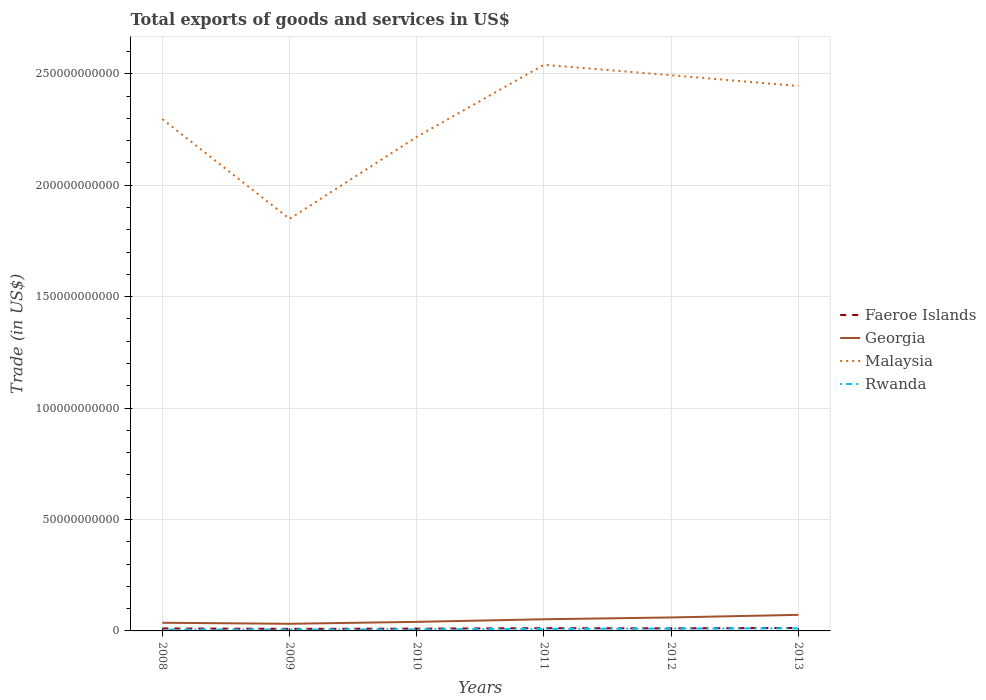How many different coloured lines are there?
Your answer should be compact. 4. Is the number of lines equal to the number of legend labels?
Your answer should be very brief. Yes. Across all years, what is the maximum total exports of goods and services in Faeroe Islands?
Keep it short and to the point. 9.34e+08. In which year was the total exports of goods and services in Georgia maximum?
Give a very brief answer. 2009. What is the total total exports of goods and services in Faeroe Islands in the graph?
Make the answer very short. -1.75e+08. What is the difference between the highest and the second highest total exports of goods and services in Georgia?
Offer a terse response. 4.01e+09. Is the total exports of goods and services in Faeroe Islands strictly greater than the total exports of goods and services in Georgia over the years?
Make the answer very short. Yes. How many lines are there?
Keep it short and to the point. 4. How many years are there in the graph?
Offer a terse response. 6. Are the values on the major ticks of Y-axis written in scientific E-notation?
Offer a very short reply. No. How are the legend labels stacked?
Provide a succinct answer. Vertical. What is the title of the graph?
Offer a very short reply. Total exports of goods and services in US$. Does "Grenada" appear as one of the legend labels in the graph?
Make the answer very short. No. What is the label or title of the X-axis?
Your answer should be very brief. Years. What is the label or title of the Y-axis?
Provide a succinct answer. Trade (in US$). What is the Trade (in US$) of Faeroe Islands in 2008?
Your answer should be compact. 1.10e+09. What is the Trade (in US$) of Georgia in 2008?
Give a very brief answer. 3.66e+09. What is the Trade (in US$) in Malaysia in 2008?
Give a very brief answer. 2.30e+11. What is the Trade (in US$) in Rwanda in 2008?
Your answer should be very brief. 6.11e+08. What is the Trade (in US$) of Faeroe Islands in 2009?
Your answer should be very brief. 9.34e+08. What is the Trade (in US$) in Georgia in 2009?
Give a very brief answer. 3.20e+09. What is the Trade (in US$) of Malaysia in 2009?
Offer a terse response. 1.85e+11. What is the Trade (in US$) of Rwanda in 2009?
Provide a succinct answer. 6.32e+08. What is the Trade (in US$) of Faeroe Islands in 2010?
Keep it short and to the point. 1.03e+09. What is the Trade (in US$) of Georgia in 2010?
Make the answer very short. 4.07e+09. What is the Trade (in US$) of Malaysia in 2010?
Your answer should be compact. 2.22e+11. What is the Trade (in US$) of Rwanda in 2010?
Your answer should be compact. 6.89e+08. What is the Trade (in US$) of Faeroe Islands in 2011?
Ensure brevity in your answer.  1.21e+09. What is the Trade (in US$) of Georgia in 2011?
Provide a succinct answer. 5.23e+09. What is the Trade (in US$) in Malaysia in 2011?
Your response must be concise. 2.54e+11. What is the Trade (in US$) in Rwanda in 2011?
Ensure brevity in your answer.  9.25e+08. What is the Trade (in US$) of Faeroe Islands in 2012?
Provide a succinct answer. 1.15e+09. What is the Trade (in US$) of Georgia in 2012?
Your response must be concise. 6.05e+09. What is the Trade (in US$) in Malaysia in 2012?
Offer a very short reply. 2.49e+11. What is the Trade (in US$) in Rwanda in 2012?
Provide a short and direct response. 1.02e+09. What is the Trade (in US$) in Faeroe Islands in 2013?
Offer a terse response. 1.32e+09. What is the Trade (in US$) in Georgia in 2013?
Provide a short and direct response. 7.21e+09. What is the Trade (in US$) of Malaysia in 2013?
Provide a succinct answer. 2.44e+11. What is the Trade (in US$) in Rwanda in 2013?
Your answer should be very brief. 1.18e+09. Across all years, what is the maximum Trade (in US$) of Faeroe Islands?
Your answer should be compact. 1.32e+09. Across all years, what is the maximum Trade (in US$) in Georgia?
Keep it short and to the point. 7.21e+09. Across all years, what is the maximum Trade (in US$) in Malaysia?
Your answer should be very brief. 2.54e+11. Across all years, what is the maximum Trade (in US$) of Rwanda?
Make the answer very short. 1.18e+09. Across all years, what is the minimum Trade (in US$) of Faeroe Islands?
Your answer should be very brief. 9.34e+08. Across all years, what is the minimum Trade (in US$) in Georgia?
Offer a very short reply. 3.20e+09. Across all years, what is the minimum Trade (in US$) in Malaysia?
Provide a succinct answer. 1.85e+11. Across all years, what is the minimum Trade (in US$) of Rwanda?
Your answer should be very brief. 6.11e+08. What is the total Trade (in US$) in Faeroe Islands in the graph?
Provide a succinct answer. 6.75e+09. What is the total Trade (in US$) of Georgia in the graph?
Provide a succinct answer. 2.94e+1. What is the total Trade (in US$) in Malaysia in the graph?
Offer a terse response. 1.38e+12. What is the total Trade (in US$) in Rwanda in the graph?
Your response must be concise. 5.05e+09. What is the difference between the Trade (in US$) of Faeroe Islands in 2008 and that in 2009?
Your answer should be compact. 1.70e+08. What is the difference between the Trade (in US$) in Georgia in 2008 and that in 2009?
Make the answer very short. 4.60e+08. What is the difference between the Trade (in US$) in Malaysia in 2008 and that in 2009?
Offer a very short reply. 4.48e+1. What is the difference between the Trade (in US$) of Rwanda in 2008 and that in 2009?
Provide a succinct answer. -2.10e+07. What is the difference between the Trade (in US$) of Faeroe Islands in 2008 and that in 2010?
Ensure brevity in your answer.  7.86e+07. What is the difference between the Trade (in US$) of Georgia in 2008 and that in 2010?
Give a very brief answer. -4.06e+08. What is the difference between the Trade (in US$) in Malaysia in 2008 and that in 2010?
Give a very brief answer. 7.97e+09. What is the difference between the Trade (in US$) of Rwanda in 2008 and that in 2010?
Keep it short and to the point. -7.86e+07. What is the difference between the Trade (in US$) in Faeroe Islands in 2008 and that in 2011?
Offer a very short reply. -1.08e+08. What is the difference between the Trade (in US$) of Georgia in 2008 and that in 2011?
Your answer should be compact. -1.57e+09. What is the difference between the Trade (in US$) in Malaysia in 2008 and that in 2011?
Your response must be concise. -2.44e+1. What is the difference between the Trade (in US$) in Rwanda in 2008 and that in 2011?
Make the answer very short. -3.14e+08. What is the difference between the Trade (in US$) of Faeroe Islands in 2008 and that in 2012?
Your answer should be very brief. -4.44e+07. What is the difference between the Trade (in US$) in Georgia in 2008 and that in 2012?
Offer a very short reply. -2.38e+09. What is the difference between the Trade (in US$) in Malaysia in 2008 and that in 2012?
Offer a terse response. -1.97e+1. What is the difference between the Trade (in US$) in Rwanda in 2008 and that in 2012?
Your answer should be very brief. -4.10e+08. What is the difference between the Trade (in US$) of Faeroe Islands in 2008 and that in 2013?
Offer a very short reply. -2.19e+08. What is the difference between the Trade (in US$) in Georgia in 2008 and that in 2013?
Provide a short and direct response. -3.55e+09. What is the difference between the Trade (in US$) in Malaysia in 2008 and that in 2013?
Make the answer very short. -1.48e+1. What is the difference between the Trade (in US$) of Rwanda in 2008 and that in 2013?
Ensure brevity in your answer.  -5.65e+08. What is the difference between the Trade (in US$) of Faeroe Islands in 2009 and that in 2010?
Offer a terse response. -9.14e+07. What is the difference between the Trade (in US$) in Georgia in 2009 and that in 2010?
Make the answer very short. -8.66e+08. What is the difference between the Trade (in US$) in Malaysia in 2009 and that in 2010?
Offer a very short reply. -3.68e+1. What is the difference between the Trade (in US$) of Rwanda in 2009 and that in 2010?
Offer a terse response. -5.77e+07. What is the difference between the Trade (in US$) of Faeroe Islands in 2009 and that in 2011?
Offer a very short reply. -2.78e+08. What is the difference between the Trade (in US$) in Georgia in 2009 and that in 2011?
Your answer should be compact. -2.03e+09. What is the difference between the Trade (in US$) of Malaysia in 2009 and that in 2011?
Provide a short and direct response. -6.91e+1. What is the difference between the Trade (in US$) of Rwanda in 2009 and that in 2011?
Your answer should be very brief. -2.93e+08. What is the difference between the Trade (in US$) of Faeroe Islands in 2009 and that in 2012?
Your answer should be compact. -2.14e+08. What is the difference between the Trade (in US$) in Georgia in 2009 and that in 2012?
Offer a very short reply. -2.84e+09. What is the difference between the Trade (in US$) in Malaysia in 2009 and that in 2012?
Make the answer very short. -6.45e+1. What is the difference between the Trade (in US$) of Rwanda in 2009 and that in 2012?
Your answer should be very brief. -3.89e+08. What is the difference between the Trade (in US$) of Faeroe Islands in 2009 and that in 2013?
Ensure brevity in your answer.  -3.89e+08. What is the difference between the Trade (in US$) in Georgia in 2009 and that in 2013?
Provide a short and direct response. -4.01e+09. What is the difference between the Trade (in US$) of Malaysia in 2009 and that in 2013?
Ensure brevity in your answer.  -5.96e+1. What is the difference between the Trade (in US$) in Rwanda in 2009 and that in 2013?
Ensure brevity in your answer.  -5.44e+08. What is the difference between the Trade (in US$) in Faeroe Islands in 2010 and that in 2011?
Your answer should be very brief. -1.87e+08. What is the difference between the Trade (in US$) in Georgia in 2010 and that in 2011?
Your answer should be compact. -1.16e+09. What is the difference between the Trade (in US$) of Malaysia in 2010 and that in 2011?
Keep it short and to the point. -3.23e+1. What is the difference between the Trade (in US$) in Rwanda in 2010 and that in 2011?
Your answer should be very brief. -2.35e+08. What is the difference between the Trade (in US$) of Faeroe Islands in 2010 and that in 2012?
Give a very brief answer. -1.23e+08. What is the difference between the Trade (in US$) in Georgia in 2010 and that in 2012?
Provide a succinct answer. -1.98e+09. What is the difference between the Trade (in US$) in Malaysia in 2010 and that in 2012?
Ensure brevity in your answer.  -2.77e+1. What is the difference between the Trade (in US$) of Rwanda in 2010 and that in 2012?
Offer a very short reply. -3.31e+08. What is the difference between the Trade (in US$) of Faeroe Islands in 2010 and that in 2013?
Make the answer very short. -2.98e+08. What is the difference between the Trade (in US$) of Georgia in 2010 and that in 2013?
Give a very brief answer. -3.15e+09. What is the difference between the Trade (in US$) in Malaysia in 2010 and that in 2013?
Provide a succinct answer. -2.28e+1. What is the difference between the Trade (in US$) in Rwanda in 2010 and that in 2013?
Your response must be concise. -4.86e+08. What is the difference between the Trade (in US$) in Faeroe Islands in 2011 and that in 2012?
Offer a very short reply. 6.40e+07. What is the difference between the Trade (in US$) in Georgia in 2011 and that in 2012?
Your response must be concise. -8.14e+08. What is the difference between the Trade (in US$) of Malaysia in 2011 and that in 2012?
Provide a short and direct response. 4.67e+09. What is the difference between the Trade (in US$) in Rwanda in 2011 and that in 2012?
Provide a short and direct response. -9.62e+07. What is the difference between the Trade (in US$) in Faeroe Islands in 2011 and that in 2013?
Provide a short and direct response. -1.11e+08. What is the difference between the Trade (in US$) in Georgia in 2011 and that in 2013?
Offer a terse response. -1.98e+09. What is the difference between the Trade (in US$) of Malaysia in 2011 and that in 2013?
Give a very brief answer. 9.53e+09. What is the difference between the Trade (in US$) of Rwanda in 2011 and that in 2013?
Give a very brief answer. -2.51e+08. What is the difference between the Trade (in US$) of Faeroe Islands in 2012 and that in 2013?
Your answer should be compact. -1.75e+08. What is the difference between the Trade (in US$) of Georgia in 2012 and that in 2013?
Your answer should be compact. -1.17e+09. What is the difference between the Trade (in US$) of Malaysia in 2012 and that in 2013?
Keep it short and to the point. 4.86e+09. What is the difference between the Trade (in US$) in Rwanda in 2012 and that in 2013?
Give a very brief answer. -1.55e+08. What is the difference between the Trade (in US$) of Faeroe Islands in 2008 and the Trade (in US$) of Georgia in 2009?
Provide a succinct answer. -2.10e+09. What is the difference between the Trade (in US$) in Faeroe Islands in 2008 and the Trade (in US$) in Malaysia in 2009?
Your response must be concise. -1.84e+11. What is the difference between the Trade (in US$) of Faeroe Islands in 2008 and the Trade (in US$) of Rwanda in 2009?
Ensure brevity in your answer.  4.73e+08. What is the difference between the Trade (in US$) in Georgia in 2008 and the Trade (in US$) in Malaysia in 2009?
Your answer should be very brief. -1.81e+11. What is the difference between the Trade (in US$) in Georgia in 2008 and the Trade (in US$) in Rwanda in 2009?
Make the answer very short. 3.03e+09. What is the difference between the Trade (in US$) of Malaysia in 2008 and the Trade (in US$) of Rwanda in 2009?
Give a very brief answer. 2.29e+11. What is the difference between the Trade (in US$) in Faeroe Islands in 2008 and the Trade (in US$) in Georgia in 2010?
Provide a succinct answer. -2.96e+09. What is the difference between the Trade (in US$) of Faeroe Islands in 2008 and the Trade (in US$) of Malaysia in 2010?
Give a very brief answer. -2.21e+11. What is the difference between the Trade (in US$) in Faeroe Islands in 2008 and the Trade (in US$) in Rwanda in 2010?
Ensure brevity in your answer.  4.15e+08. What is the difference between the Trade (in US$) in Georgia in 2008 and the Trade (in US$) in Malaysia in 2010?
Keep it short and to the point. -2.18e+11. What is the difference between the Trade (in US$) of Georgia in 2008 and the Trade (in US$) of Rwanda in 2010?
Offer a very short reply. 2.97e+09. What is the difference between the Trade (in US$) in Malaysia in 2008 and the Trade (in US$) in Rwanda in 2010?
Your answer should be compact. 2.29e+11. What is the difference between the Trade (in US$) of Faeroe Islands in 2008 and the Trade (in US$) of Georgia in 2011?
Offer a very short reply. -4.13e+09. What is the difference between the Trade (in US$) in Faeroe Islands in 2008 and the Trade (in US$) in Malaysia in 2011?
Keep it short and to the point. -2.53e+11. What is the difference between the Trade (in US$) of Faeroe Islands in 2008 and the Trade (in US$) of Rwanda in 2011?
Provide a short and direct response. 1.80e+08. What is the difference between the Trade (in US$) in Georgia in 2008 and the Trade (in US$) in Malaysia in 2011?
Provide a succinct answer. -2.50e+11. What is the difference between the Trade (in US$) in Georgia in 2008 and the Trade (in US$) in Rwanda in 2011?
Ensure brevity in your answer.  2.74e+09. What is the difference between the Trade (in US$) of Malaysia in 2008 and the Trade (in US$) of Rwanda in 2011?
Provide a succinct answer. 2.29e+11. What is the difference between the Trade (in US$) of Faeroe Islands in 2008 and the Trade (in US$) of Georgia in 2012?
Keep it short and to the point. -4.94e+09. What is the difference between the Trade (in US$) of Faeroe Islands in 2008 and the Trade (in US$) of Malaysia in 2012?
Provide a succinct answer. -2.48e+11. What is the difference between the Trade (in US$) in Faeroe Islands in 2008 and the Trade (in US$) in Rwanda in 2012?
Make the answer very short. 8.36e+07. What is the difference between the Trade (in US$) in Georgia in 2008 and the Trade (in US$) in Malaysia in 2012?
Keep it short and to the point. -2.46e+11. What is the difference between the Trade (in US$) of Georgia in 2008 and the Trade (in US$) of Rwanda in 2012?
Your response must be concise. 2.64e+09. What is the difference between the Trade (in US$) of Malaysia in 2008 and the Trade (in US$) of Rwanda in 2012?
Provide a succinct answer. 2.29e+11. What is the difference between the Trade (in US$) of Faeroe Islands in 2008 and the Trade (in US$) of Georgia in 2013?
Your response must be concise. -6.11e+09. What is the difference between the Trade (in US$) of Faeroe Islands in 2008 and the Trade (in US$) of Malaysia in 2013?
Ensure brevity in your answer.  -2.43e+11. What is the difference between the Trade (in US$) of Faeroe Islands in 2008 and the Trade (in US$) of Rwanda in 2013?
Offer a very short reply. -7.10e+07. What is the difference between the Trade (in US$) of Georgia in 2008 and the Trade (in US$) of Malaysia in 2013?
Give a very brief answer. -2.41e+11. What is the difference between the Trade (in US$) of Georgia in 2008 and the Trade (in US$) of Rwanda in 2013?
Your response must be concise. 2.49e+09. What is the difference between the Trade (in US$) in Malaysia in 2008 and the Trade (in US$) in Rwanda in 2013?
Provide a succinct answer. 2.28e+11. What is the difference between the Trade (in US$) in Faeroe Islands in 2009 and the Trade (in US$) in Georgia in 2010?
Keep it short and to the point. -3.13e+09. What is the difference between the Trade (in US$) in Faeroe Islands in 2009 and the Trade (in US$) in Malaysia in 2010?
Offer a terse response. -2.21e+11. What is the difference between the Trade (in US$) of Faeroe Islands in 2009 and the Trade (in US$) of Rwanda in 2010?
Make the answer very short. 2.45e+08. What is the difference between the Trade (in US$) of Georgia in 2009 and the Trade (in US$) of Malaysia in 2010?
Offer a terse response. -2.18e+11. What is the difference between the Trade (in US$) in Georgia in 2009 and the Trade (in US$) in Rwanda in 2010?
Your answer should be very brief. 2.51e+09. What is the difference between the Trade (in US$) of Malaysia in 2009 and the Trade (in US$) of Rwanda in 2010?
Your answer should be very brief. 1.84e+11. What is the difference between the Trade (in US$) in Faeroe Islands in 2009 and the Trade (in US$) in Georgia in 2011?
Your answer should be very brief. -4.30e+09. What is the difference between the Trade (in US$) of Faeroe Islands in 2009 and the Trade (in US$) of Malaysia in 2011?
Provide a short and direct response. -2.53e+11. What is the difference between the Trade (in US$) of Faeroe Islands in 2009 and the Trade (in US$) of Rwanda in 2011?
Your answer should be compact. 9.84e+06. What is the difference between the Trade (in US$) of Georgia in 2009 and the Trade (in US$) of Malaysia in 2011?
Your answer should be compact. -2.51e+11. What is the difference between the Trade (in US$) of Georgia in 2009 and the Trade (in US$) of Rwanda in 2011?
Your response must be concise. 2.28e+09. What is the difference between the Trade (in US$) of Malaysia in 2009 and the Trade (in US$) of Rwanda in 2011?
Make the answer very short. 1.84e+11. What is the difference between the Trade (in US$) in Faeroe Islands in 2009 and the Trade (in US$) in Georgia in 2012?
Your answer should be very brief. -5.11e+09. What is the difference between the Trade (in US$) in Faeroe Islands in 2009 and the Trade (in US$) in Malaysia in 2012?
Your answer should be compact. -2.48e+11. What is the difference between the Trade (in US$) of Faeroe Islands in 2009 and the Trade (in US$) of Rwanda in 2012?
Provide a succinct answer. -8.63e+07. What is the difference between the Trade (in US$) of Georgia in 2009 and the Trade (in US$) of Malaysia in 2012?
Give a very brief answer. -2.46e+11. What is the difference between the Trade (in US$) of Georgia in 2009 and the Trade (in US$) of Rwanda in 2012?
Provide a short and direct response. 2.18e+09. What is the difference between the Trade (in US$) of Malaysia in 2009 and the Trade (in US$) of Rwanda in 2012?
Offer a terse response. 1.84e+11. What is the difference between the Trade (in US$) in Faeroe Islands in 2009 and the Trade (in US$) in Georgia in 2013?
Offer a terse response. -6.28e+09. What is the difference between the Trade (in US$) of Faeroe Islands in 2009 and the Trade (in US$) of Malaysia in 2013?
Make the answer very short. -2.44e+11. What is the difference between the Trade (in US$) of Faeroe Islands in 2009 and the Trade (in US$) of Rwanda in 2013?
Your answer should be compact. -2.41e+08. What is the difference between the Trade (in US$) in Georgia in 2009 and the Trade (in US$) in Malaysia in 2013?
Offer a very short reply. -2.41e+11. What is the difference between the Trade (in US$) of Georgia in 2009 and the Trade (in US$) of Rwanda in 2013?
Offer a terse response. 2.03e+09. What is the difference between the Trade (in US$) of Malaysia in 2009 and the Trade (in US$) of Rwanda in 2013?
Offer a terse response. 1.84e+11. What is the difference between the Trade (in US$) in Faeroe Islands in 2010 and the Trade (in US$) in Georgia in 2011?
Ensure brevity in your answer.  -4.21e+09. What is the difference between the Trade (in US$) of Faeroe Islands in 2010 and the Trade (in US$) of Malaysia in 2011?
Offer a very short reply. -2.53e+11. What is the difference between the Trade (in US$) of Faeroe Islands in 2010 and the Trade (in US$) of Rwanda in 2011?
Keep it short and to the point. 1.01e+08. What is the difference between the Trade (in US$) in Georgia in 2010 and the Trade (in US$) in Malaysia in 2011?
Make the answer very short. -2.50e+11. What is the difference between the Trade (in US$) in Georgia in 2010 and the Trade (in US$) in Rwanda in 2011?
Make the answer very short. 3.14e+09. What is the difference between the Trade (in US$) in Malaysia in 2010 and the Trade (in US$) in Rwanda in 2011?
Provide a succinct answer. 2.21e+11. What is the difference between the Trade (in US$) in Faeroe Islands in 2010 and the Trade (in US$) in Georgia in 2012?
Offer a very short reply. -5.02e+09. What is the difference between the Trade (in US$) in Faeroe Islands in 2010 and the Trade (in US$) in Malaysia in 2012?
Give a very brief answer. -2.48e+11. What is the difference between the Trade (in US$) in Faeroe Islands in 2010 and the Trade (in US$) in Rwanda in 2012?
Your response must be concise. 5.09e+06. What is the difference between the Trade (in US$) of Georgia in 2010 and the Trade (in US$) of Malaysia in 2012?
Keep it short and to the point. -2.45e+11. What is the difference between the Trade (in US$) of Georgia in 2010 and the Trade (in US$) of Rwanda in 2012?
Your answer should be compact. 3.05e+09. What is the difference between the Trade (in US$) of Malaysia in 2010 and the Trade (in US$) of Rwanda in 2012?
Ensure brevity in your answer.  2.21e+11. What is the difference between the Trade (in US$) of Faeroe Islands in 2010 and the Trade (in US$) of Georgia in 2013?
Offer a terse response. -6.19e+09. What is the difference between the Trade (in US$) of Faeroe Islands in 2010 and the Trade (in US$) of Malaysia in 2013?
Offer a terse response. -2.43e+11. What is the difference between the Trade (in US$) in Faeroe Islands in 2010 and the Trade (in US$) in Rwanda in 2013?
Offer a very short reply. -1.50e+08. What is the difference between the Trade (in US$) of Georgia in 2010 and the Trade (in US$) of Malaysia in 2013?
Offer a terse response. -2.40e+11. What is the difference between the Trade (in US$) of Georgia in 2010 and the Trade (in US$) of Rwanda in 2013?
Make the answer very short. 2.89e+09. What is the difference between the Trade (in US$) in Malaysia in 2010 and the Trade (in US$) in Rwanda in 2013?
Your answer should be compact. 2.21e+11. What is the difference between the Trade (in US$) of Faeroe Islands in 2011 and the Trade (in US$) of Georgia in 2012?
Provide a succinct answer. -4.83e+09. What is the difference between the Trade (in US$) in Faeroe Islands in 2011 and the Trade (in US$) in Malaysia in 2012?
Ensure brevity in your answer.  -2.48e+11. What is the difference between the Trade (in US$) in Faeroe Islands in 2011 and the Trade (in US$) in Rwanda in 2012?
Keep it short and to the point. 1.92e+08. What is the difference between the Trade (in US$) in Georgia in 2011 and the Trade (in US$) in Malaysia in 2012?
Give a very brief answer. -2.44e+11. What is the difference between the Trade (in US$) in Georgia in 2011 and the Trade (in US$) in Rwanda in 2012?
Give a very brief answer. 4.21e+09. What is the difference between the Trade (in US$) of Malaysia in 2011 and the Trade (in US$) of Rwanda in 2012?
Provide a short and direct response. 2.53e+11. What is the difference between the Trade (in US$) of Faeroe Islands in 2011 and the Trade (in US$) of Georgia in 2013?
Offer a very short reply. -6.00e+09. What is the difference between the Trade (in US$) of Faeroe Islands in 2011 and the Trade (in US$) of Malaysia in 2013?
Give a very brief answer. -2.43e+11. What is the difference between the Trade (in US$) in Faeroe Islands in 2011 and the Trade (in US$) in Rwanda in 2013?
Your answer should be very brief. 3.75e+07. What is the difference between the Trade (in US$) of Georgia in 2011 and the Trade (in US$) of Malaysia in 2013?
Make the answer very short. -2.39e+11. What is the difference between the Trade (in US$) in Georgia in 2011 and the Trade (in US$) in Rwanda in 2013?
Give a very brief answer. 4.06e+09. What is the difference between the Trade (in US$) in Malaysia in 2011 and the Trade (in US$) in Rwanda in 2013?
Offer a terse response. 2.53e+11. What is the difference between the Trade (in US$) of Faeroe Islands in 2012 and the Trade (in US$) of Georgia in 2013?
Keep it short and to the point. -6.06e+09. What is the difference between the Trade (in US$) of Faeroe Islands in 2012 and the Trade (in US$) of Malaysia in 2013?
Give a very brief answer. -2.43e+11. What is the difference between the Trade (in US$) in Faeroe Islands in 2012 and the Trade (in US$) in Rwanda in 2013?
Make the answer very short. -2.66e+07. What is the difference between the Trade (in US$) of Georgia in 2012 and the Trade (in US$) of Malaysia in 2013?
Your answer should be very brief. -2.38e+11. What is the difference between the Trade (in US$) in Georgia in 2012 and the Trade (in US$) in Rwanda in 2013?
Make the answer very short. 4.87e+09. What is the difference between the Trade (in US$) of Malaysia in 2012 and the Trade (in US$) of Rwanda in 2013?
Your answer should be compact. 2.48e+11. What is the average Trade (in US$) of Faeroe Islands per year?
Your answer should be compact. 1.12e+09. What is the average Trade (in US$) of Georgia per year?
Your response must be concise. 4.90e+09. What is the average Trade (in US$) in Malaysia per year?
Offer a very short reply. 2.31e+11. What is the average Trade (in US$) in Rwanda per year?
Ensure brevity in your answer.  8.42e+08. In the year 2008, what is the difference between the Trade (in US$) of Faeroe Islands and Trade (in US$) of Georgia?
Keep it short and to the point. -2.56e+09. In the year 2008, what is the difference between the Trade (in US$) in Faeroe Islands and Trade (in US$) in Malaysia?
Keep it short and to the point. -2.29e+11. In the year 2008, what is the difference between the Trade (in US$) in Faeroe Islands and Trade (in US$) in Rwanda?
Provide a short and direct response. 4.94e+08. In the year 2008, what is the difference between the Trade (in US$) in Georgia and Trade (in US$) in Malaysia?
Provide a short and direct response. -2.26e+11. In the year 2008, what is the difference between the Trade (in US$) of Georgia and Trade (in US$) of Rwanda?
Provide a succinct answer. 3.05e+09. In the year 2008, what is the difference between the Trade (in US$) in Malaysia and Trade (in US$) in Rwanda?
Your answer should be compact. 2.29e+11. In the year 2009, what is the difference between the Trade (in US$) in Faeroe Islands and Trade (in US$) in Georgia?
Provide a succinct answer. -2.27e+09. In the year 2009, what is the difference between the Trade (in US$) in Faeroe Islands and Trade (in US$) in Malaysia?
Make the answer very short. -1.84e+11. In the year 2009, what is the difference between the Trade (in US$) in Faeroe Islands and Trade (in US$) in Rwanda?
Your response must be concise. 3.03e+08. In the year 2009, what is the difference between the Trade (in US$) of Georgia and Trade (in US$) of Malaysia?
Keep it short and to the point. -1.82e+11. In the year 2009, what is the difference between the Trade (in US$) in Georgia and Trade (in US$) in Rwanda?
Offer a very short reply. 2.57e+09. In the year 2009, what is the difference between the Trade (in US$) of Malaysia and Trade (in US$) of Rwanda?
Your answer should be compact. 1.84e+11. In the year 2010, what is the difference between the Trade (in US$) in Faeroe Islands and Trade (in US$) in Georgia?
Provide a short and direct response. -3.04e+09. In the year 2010, what is the difference between the Trade (in US$) in Faeroe Islands and Trade (in US$) in Malaysia?
Provide a succinct answer. -2.21e+11. In the year 2010, what is the difference between the Trade (in US$) of Faeroe Islands and Trade (in US$) of Rwanda?
Offer a terse response. 3.36e+08. In the year 2010, what is the difference between the Trade (in US$) in Georgia and Trade (in US$) in Malaysia?
Make the answer very short. -2.18e+11. In the year 2010, what is the difference between the Trade (in US$) in Georgia and Trade (in US$) in Rwanda?
Offer a terse response. 3.38e+09. In the year 2010, what is the difference between the Trade (in US$) of Malaysia and Trade (in US$) of Rwanda?
Ensure brevity in your answer.  2.21e+11. In the year 2011, what is the difference between the Trade (in US$) in Faeroe Islands and Trade (in US$) in Georgia?
Your answer should be very brief. -4.02e+09. In the year 2011, what is the difference between the Trade (in US$) of Faeroe Islands and Trade (in US$) of Malaysia?
Provide a short and direct response. -2.53e+11. In the year 2011, what is the difference between the Trade (in US$) of Faeroe Islands and Trade (in US$) of Rwanda?
Keep it short and to the point. 2.88e+08. In the year 2011, what is the difference between the Trade (in US$) in Georgia and Trade (in US$) in Malaysia?
Provide a succinct answer. -2.49e+11. In the year 2011, what is the difference between the Trade (in US$) in Georgia and Trade (in US$) in Rwanda?
Your answer should be very brief. 4.31e+09. In the year 2011, what is the difference between the Trade (in US$) in Malaysia and Trade (in US$) in Rwanda?
Your answer should be compact. 2.53e+11. In the year 2012, what is the difference between the Trade (in US$) in Faeroe Islands and Trade (in US$) in Georgia?
Keep it short and to the point. -4.90e+09. In the year 2012, what is the difference between the Trade (in US$) of Faeroe Islands and Trade (in US$) of Malaysia?
Make the answer very short. -2.48e+11. In the year 2012, what is the difference between the Trade (in US$) in Faeroe Islands and Trade (in US$) in Rwanda?
Offer a very short reply. 1.28e+08. In the year 2012, what is the difference between the Trade (in US$) in Georgia and Trade (in US$) in Malaysia?
Make the answer very short. -2.43e+11. In the year 2012, what is the difference between the Trade (in US$) in Georgia and Trade (in US$) in Rwanda?
Offer a terse response. 5.02e+09. In the year 2012, what is the difference between the Trade (in US$) of Malaysia and Trade (in US$) of Rwanda?
Provide a succinct answer. 2.48e+11. In the year 2013, what is the difference between the Trade (in US$) of Faeroe Islands and Trade (in US$) of Georgia?
Offer a very short reply. -5.89e+09. In the year 2013, what is the difference between the Trade (in US$) of Faeroe Islands and Trade (in US$) of Malaysia?
Give a very brief answer. -2.43e+11. In the year 2013, what is the difference between the Trade (in US$) in Faeroe Islands and Trade (in US$) in Rwanda?
Make the answer very short. 1.48e+08. In the year 2013, what is the difference between the Trade (in US$) of Georgia and Trade (in US$) of Malaysia?
Offer a terse response. -2.37e+11. In the year 2013, what is the difference between the Trade (in US$) of Georgia and Trade (in US$) of Rwanda?
Keep it short and to the point. 6.04e+09. In the year 2013, what is the difference between the Trade (in US$) in Malaysia and Trade (in US$) in Rwanda?
Make the answer very short. 2.43e+11. What is the ratio of the Trade (in US$) in Faeroe Islands in 2008 to that in 2009?
Provide a short and direct response. 1.18. What is the ratio of the Trade (in US$) in Georgia in 2008 to that in 2009?
Make the answer very short. 1.14. What is the ratio of the Trade (in US$) in Malaysia in 2008 to that in 2009?
Your response must be concise. 1.24. What is the ratio of the Trade (in US$) in Rwanda in 2008 to that in 2009?
Your answer should be compact. 0.97. What is the ratio of the Trade (in US$) in Faeroe Islands in 2008 to that in 2010?
Provide a succinct answer. 1.08. What is the ratio of the Trade (in US$) of Georgia in 2008 to that in 2010?
Keep it short and to the point. 0.9. What is the ratio of the Trade (in US$) in Malaysia in 2008 to that in 2010?
Ensure brevity in your answer.  1.04. What is the ratio of the Trade (in US$) in Rwanda in 2008 to that in 2010?
Your answer should be very brief. 0.89. What is the ratio of the Trade (in US$) of Faeroe Islands in 2008 to that in 2011?
Provide a succinct answer. 0.91. What is the ratio of the Trade (in US$) of Malaysia in 2008 to that in 2011?
Offer a terse response. 0.9. What is the ratio of the Trade (in US$) in Rwanda in 2008 to that in 2011?
Offer a very short reply. 0.66. What is the ratio of the Trade (in US$) of Faeroe Islands in 2008 to that in 2012?
Ensure brevity in your answer.  0.96. What is the ratio of the Trade (in US$) in Georgia in 2008 to that in 2012?
Your answer should be compact. 0.61. What is the ratio of the Trade (in US$) in Malaysia in 2008 to that in 2012?
Ensure brevity in your answer.  0.92. What is the ratio of the Trade (in US$) of Rwanda in 2008 to that in 2012?
Your answer should be very brief. 0.6. What is the ratio of the Trade (in US$) in Faeroe Islands in 2008 to that in 2013?
Ensure brevity in your answer.  0.83. What is the ratio of the Trade (in US$) of Georgia in 2008 to that in 2013?
Your response must be concise. 0.51. What is the ratio of the Trade (in US$) of Malaysia in 2008 to that in 2013?
Provide a succinct answer. 0.94. What is the ratio of the Trade (in US$) in Rwanda in 2008 to that in 2013?
Keep it short and to the point. 0.52. What is the ratio of the Trade (in US$) of Faeroe Islands in 2009 to that in 2010?
Keep it short and to the point. 0.91. What is the ratio of the Trade (in US$) in Georgia in 2009 to that in 2010?
Ensure brevity in your answer.  0.79. What is the ratio of the Trade (in US$) of Malaysia in 2009 to that in 2010?
Your response must be concise. 0.83. What is the ratio of the Trade (in US$) in Rwanda in 2009 to that in 2010?
Your response must be concise. 0.92. What is the ratio of the Trade (in US$) in Faeroe Islands in 2009 to that in 2011?
Make the answer very short. 0.77. What is the ratio of the Trade (in US$) of Georgia in 2009 to that in 2011?
Provide a short and direct response. 0.61. What is the ratio of the Trade (in US$) in Malaysia in 2009 to that in 2011?
Provide a short and direct response. 0.73. What is the ratio of the Trade (in US$) of Rwanda in 2009 to that in 2011?
Give a very brief answer. 0.68. What is the ratio of the Trade (in US$) in Faeroe Islands in 2009 to that in 2012?
Provide a short and direct response. 0.81. What is the ratio of the Trade (in US$) in Georgia in 2009 to that in 2012?
Provide a short and direct response. 0.53. What is the ratio of the Trade (in US$) in Malaysia in 2009 to that in 2012?
Give a very brief answer. 0.74. What is the ratio of the Trade (in US$) in Rwanda in 2009 to that in 2012?
Offer a very short reply. 0.62. What is the ratio of the Trade (in US$) in Faeroe Islands in 2009 to that in 2013?
Provide a short and direct response. 0.71. What is the ratio of the Trade (in US$) of Georgia in 2009 to that in 2013?
Keep it short and to the point. 0.44. What is the ratio of the Trade (in US$) in Malaysia in 2009 to that in 2013?
Offer a very short reply. 0.76. What is the ratio of the Trade (in US$) in Rwanda in 2009 to that in 2013?
Your answer should be compact. 0.54. What is the ratio of the Trade (in US$) in Faeroe Islands in 2010 to that in 2011?
Your answer should be very brief. 0.85. What is the ratio of the Trade (in US$) of Georgia in 2010 to that in 2011?
Your response must be concise. 0.78. What is the ratio of the Trade (in US$) in Malaysia in 2010 to that in 2011?
Provide a short and direct response. 0.87. What is the ratio of the Trade (in US$) in Rwanda in 2010 to that in 2011?
Your answer should be very brief. 0.75. What is the ratio of the Trade (in US$) of Faeroe Islands in 2010 to that in 2012?
Your answer should be compact. 0.89. What is the ratio of the Trade (in US$) of Georgia in 2010 to that in 2012?
Make the answer very short. 0.67. What is the ratio of the Trade (in US$) of Malaysia in 2010 to that in 2012?
Provide a succinct answer. 0.89. What is the ratio of the Trade (in US$) of Rwanda in 2010 to that in 2012?
Ensure brevity in your answer.  0.68. What is the ratio of the Trade (in US$) of Faeroe Islands in 2010 to that in 2013?
Ensure brevity in your answer.  0.78. What is the ratio of the Trade (in US$) of Georgia in 2010 to that in 2013?
Offer a terse response. 0.56. What is the ratio of the Trade (in US$) in Malaysia in 2010 to that in 2013?
Make the answer very short. 0.91. What is the ratio of the Trade (in US$) in Rwanda in 2010 to that in 2013?
Give a very brief answer. 0.59. What is the ratio of the Trade (in US$) in Faeroe Islands in 2011 to that in 2012?
Provide a short and direct response. 1.06. What is the ratio of the Trade (in US$) in Georgia in 2011 to that in 2012?
Make the answer very short. 0.87. What is the ratio of the Trade (in US$) of Malaysia in 2011 to that in 2012?
Make the answer very short. 1.02. What is the ratio of the Trade (in US$) of Rwanda in 2011 to that in 2012?
Your answer should be compact. 0.91. What is the ratio of the Trade (in US$) of Faeroe Islands in 2011 to that in 2013?
Offer a terse response. 0.92. What is the ratio of the Trade (in US$) in Georgia in 2011 to that in 2013?
Offer a very short reply. 0.73. What is the ratio of the Trade (in US$) of Malaysia in 2011 to that in 2013?
Your answer should be very brief. 1.04. What is the ratio of the Trade (in US$) of Rwanda in 2011 to that in 2013?
Your response must be concise. 0.79. What is the ratio of the Trade (in US$) in Faeroe Islands in 2012 to that in 2013?
Offer a terse response. 0.87. What is the ratio of the Trade (in US$) of Georgia in 2012 to that in 2013?
Ensure brevity in your answer.  0.84. What is the ratio of the Trade (in US$) in Malaysia in 2012 to that in 2013?
Your answer should be compact. 1.02. What is the ratio of the Trade (in US$) of Rwanda in 2012 to that in 2013?
Keep it short and to the point. 0.87. What is the difference between the highest and the second highest Trade (in US$) of Faeroe Islands?
Offer a terse response. 1.11e+08. What is the difference between the highest and the second highest Trade (in US$) in Georgia?
Provide a succinct answer. 1.17e+09. What is the difference between the highest and the second highest Trade (in US$) in Malaysia?
Provide a succinct answer. 4.67e+09. What is the difference between the highest and the second highest Trade (in US$) of Rwanda?
Offer a very short reply. 1.55e+08. What is the difference between the highest and the lowest Trade (in US$) in Faeroe Islands?
Your response must be concise. 3.89e+08. What is the difference between the highest and the lowest Trade (in US$) in Georgia?
Your answer should be compact. 4.01e+09. What is the difference between the highest and the lowest Trade (in US$) in Malaysia?
Make the answer very short. 6.91e+1. What is the difference between the highest and the lowest Trade (in US$) in Rwanda?
Offer a very short reply. 5.65e+08. 